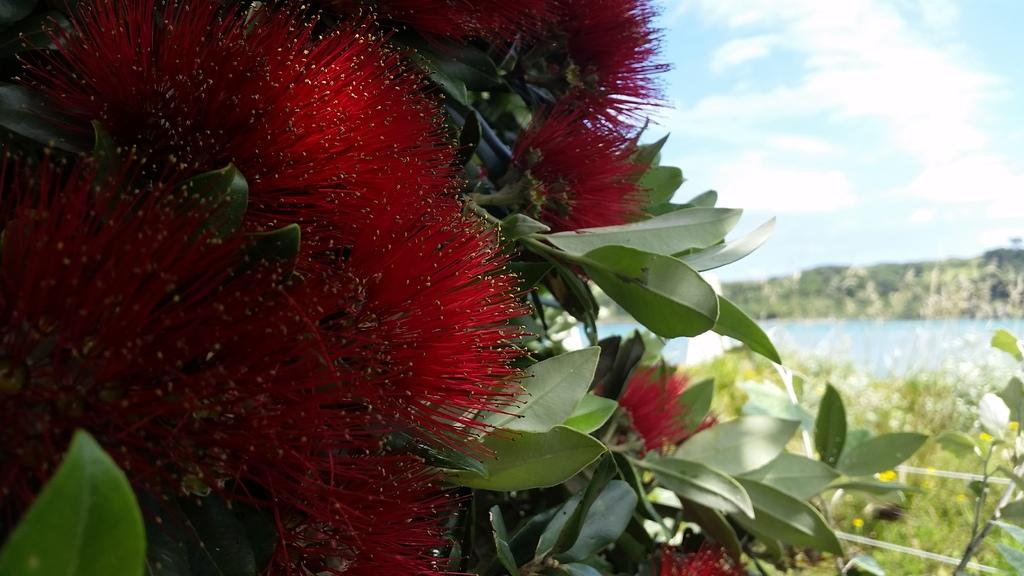What type of vegetation can be seen in the image? There are flowers, leaves, and plants visible in the image. What else is present in the image besides vegetation? There is water visible in the image. What can be seen in the background of the image? The sky is visible in the background of the image. Where is the swing located in the image? There is no swing present in the image. What type of ship can be seen sailing in the water in the image? There is no ship visible in the image; only water is present. 